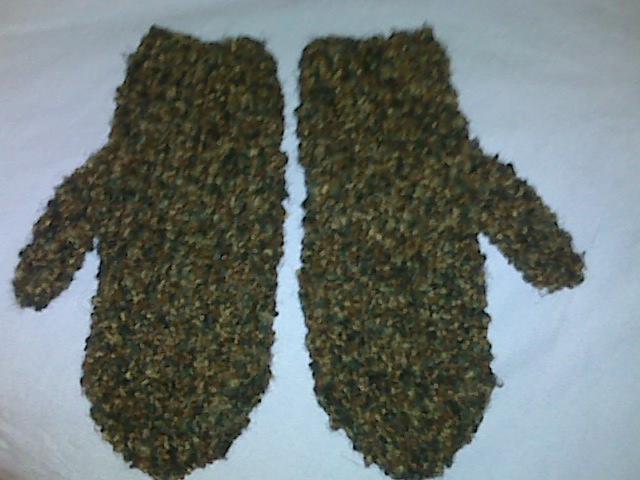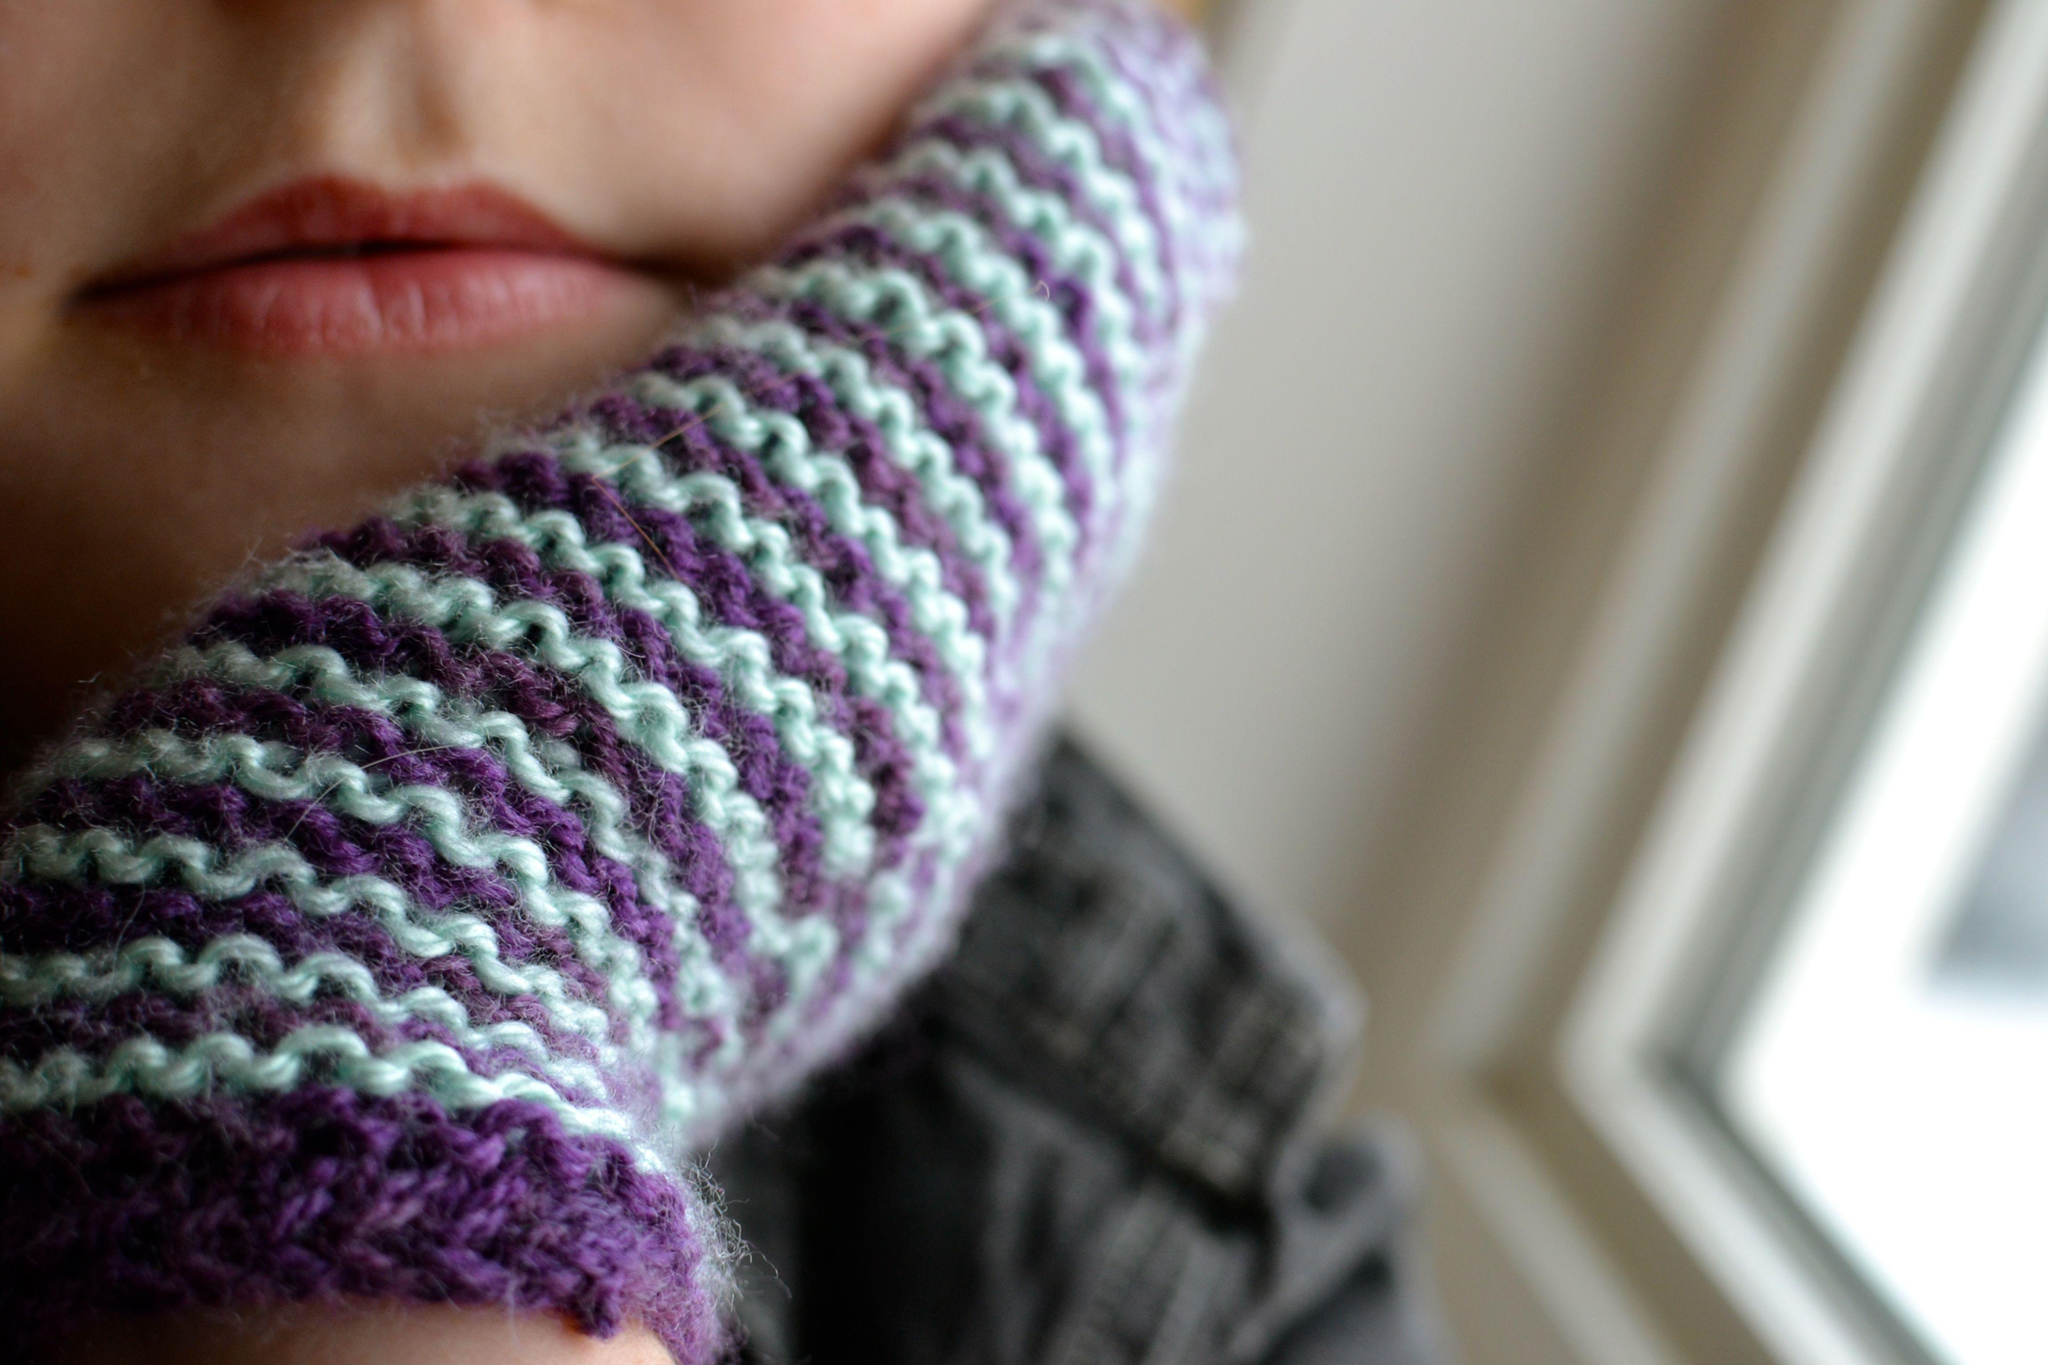The first image is the image on the left, the second image is the image on the right. Assess this claim about the two images: "There are no less than three mittens". Correct or not? Answer yes or no. Yes. 